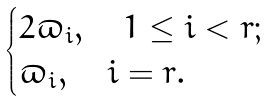<formula> <loc_0><loc_0><loc_500><loc_500>\begin{cases} 2 \varpi _ { i } , \quad 1 \leq i < r ; \\ \varpi _ { i } , \quad i = r . \end{cases}</formula> 